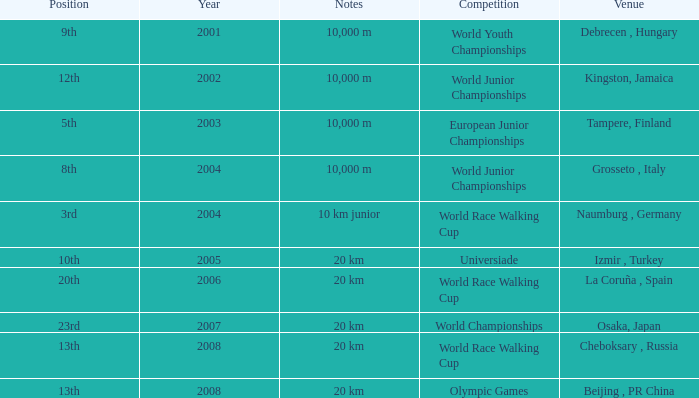In which venue did he place 3rd in the World Race Walking Cup? Naumburg , Germany. 